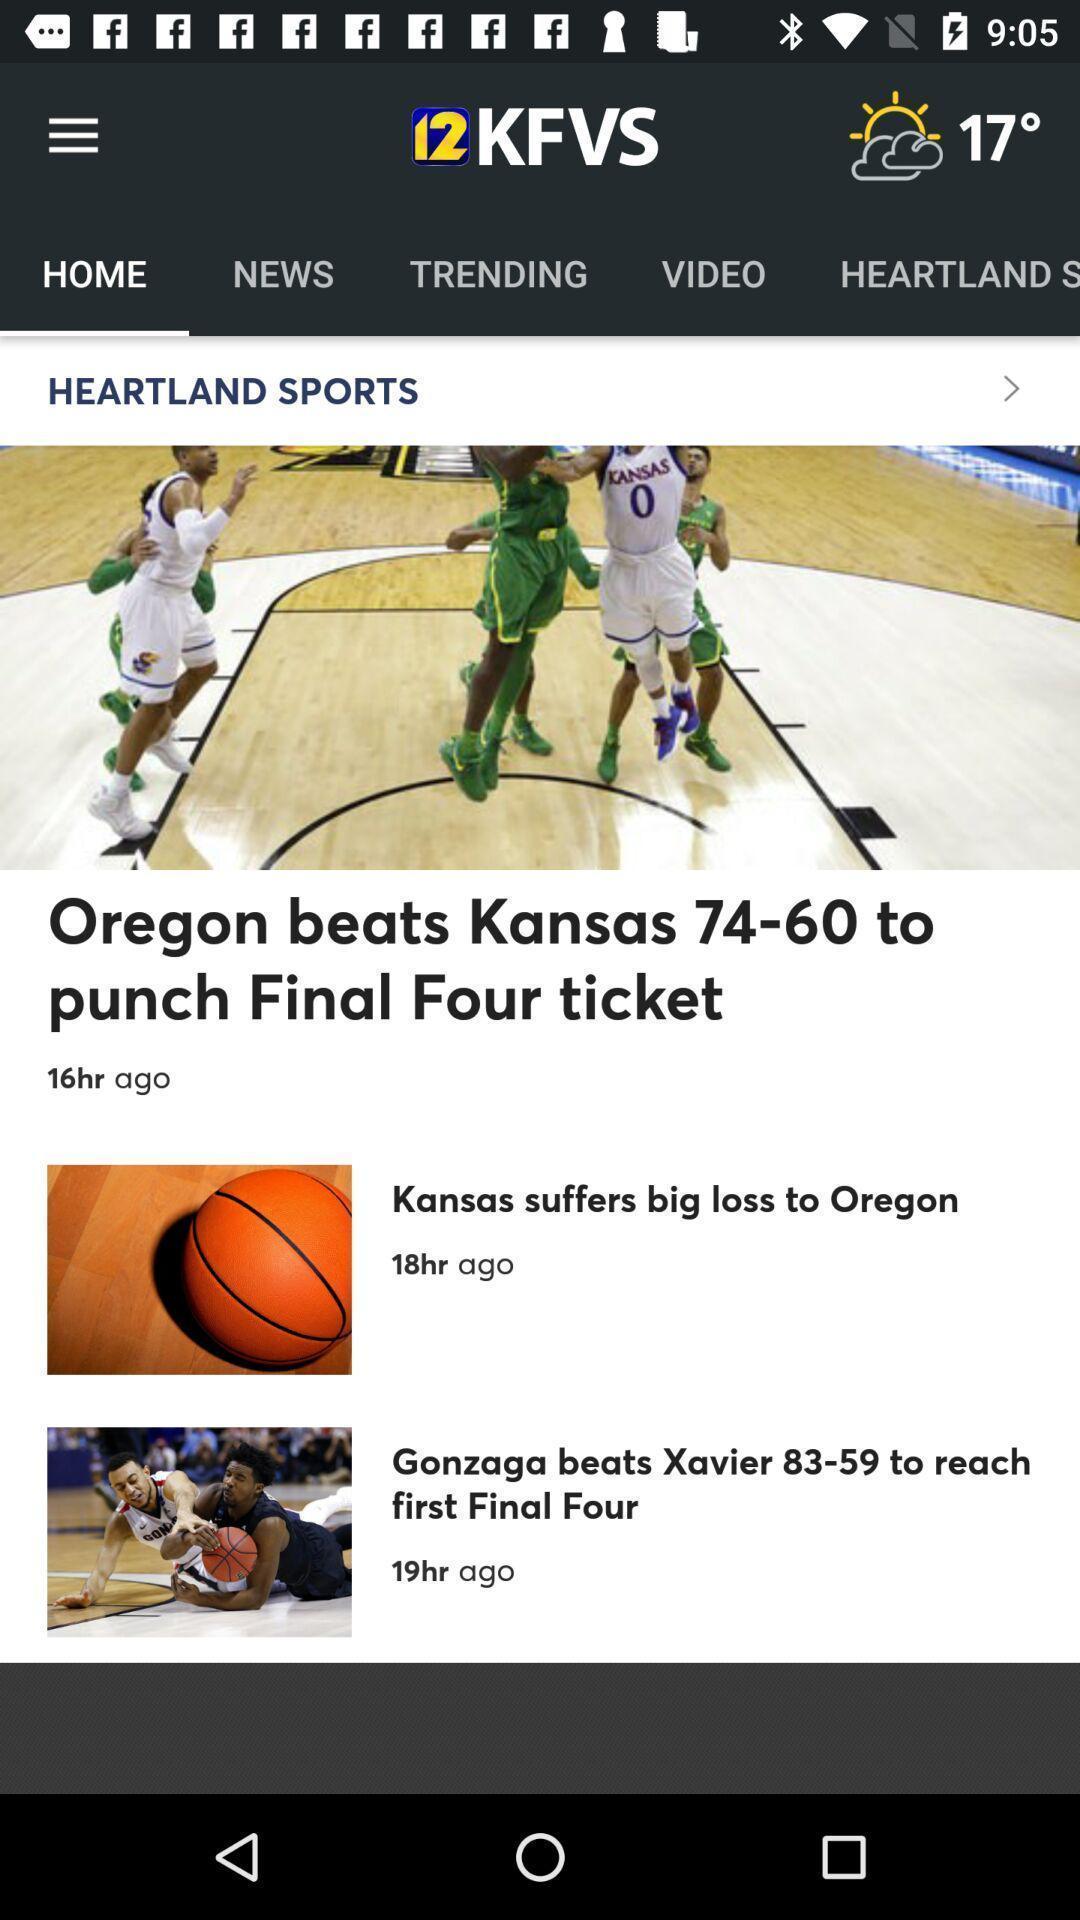Provide a textual representation of this image. Screen shows multiple articles in a news app. 